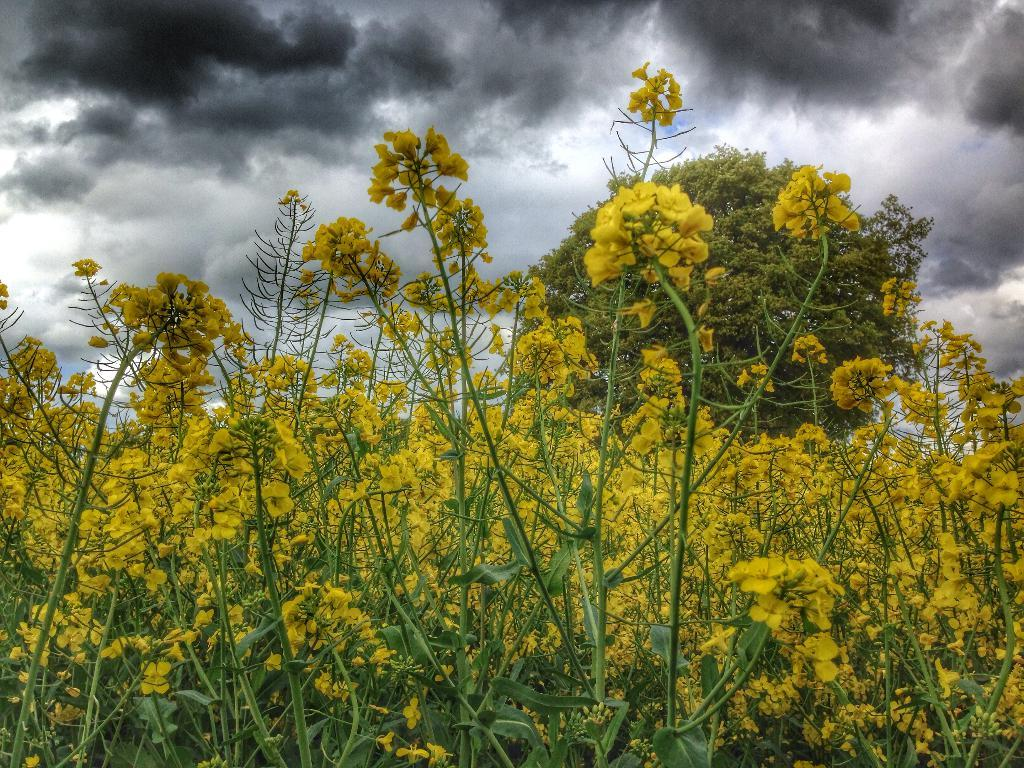What type of flora can be seen in the image? There are flowers, plants, and a tree in the image. What part of the natural environment is visible in the image? The sky is visible in the image. What can be seen in the sky in the image? There are clouds in the image. What type of credit card is the robin holding in the image? There is no robin or credit card present in the image. 